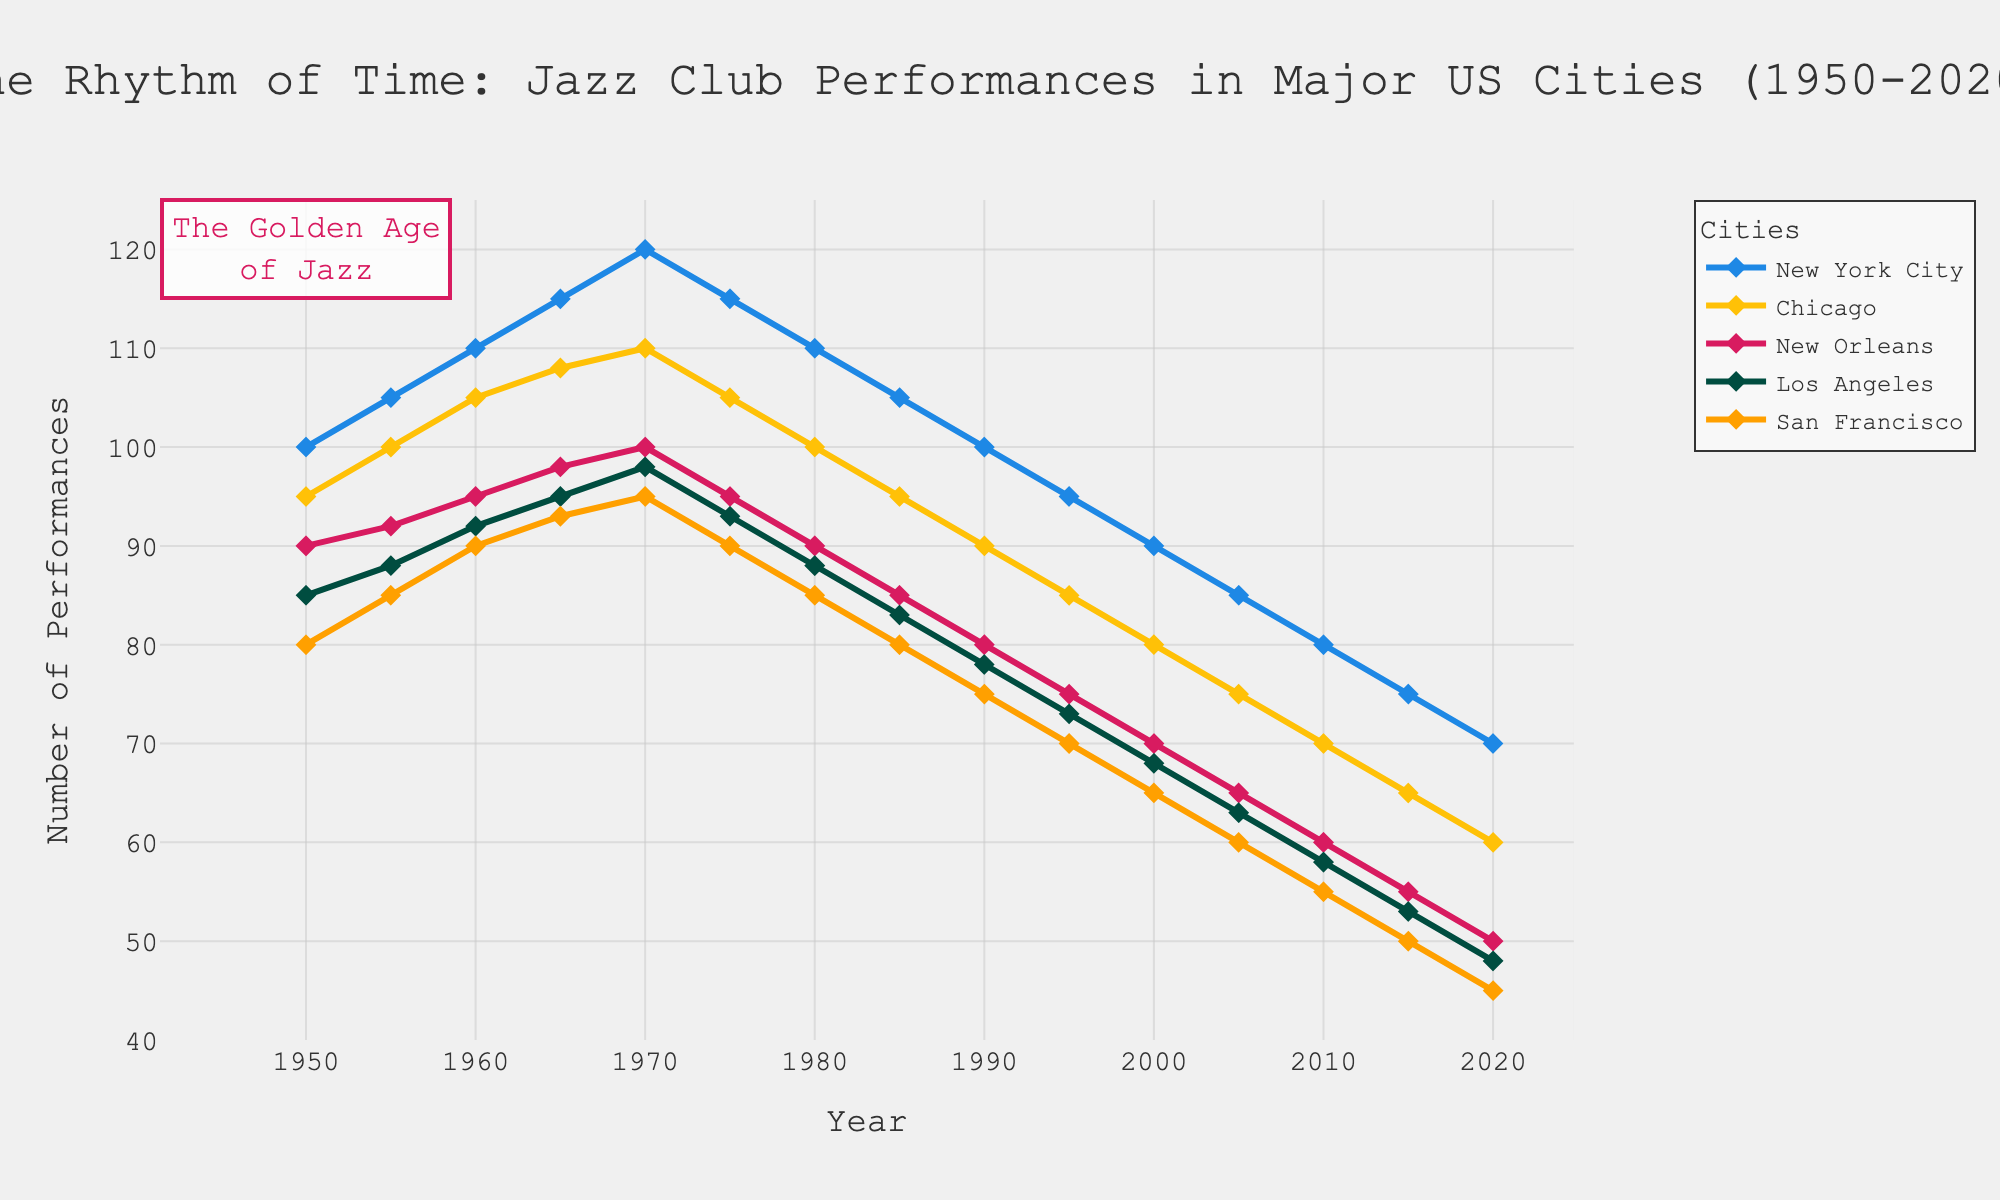Which city had the highest number of performances in 1970? By observing the line chart, we can see that New York City had the highest number of performances in 1970.
Answer: New York City How many performances did New Orleans have in 1985, and how does that compare to the number in 1950? New Orleans had 85 performances in 1985. By looking at 1950, we see it had 90 performances. Comparing the two, in 1985 there was 5 performances fewer than in 1950.
Answer: 85 in 1985, 5 fewer than in 1950 What is the average number of performances in Chicago from 2000 to 2020? The number of performances in Chicago from 2000 to 2020 is 80, 75, 70, 65, 60. Summing these up (80 + 75 + 70 + 65 + 60) = 350, and there are 5 data points, so the average is 350 / 5 = 70
Answer: 70 Which city showed the most significant decline in performances from 1950 to 2020? By comparing the drop in performances from 1950 to 2020 for each city, we see that New York City had 100 performances in 1950, which fell to 70 by 2020, a decline of 30, the largest among the cities.
Answer: New York City Between which consecutive decades did San Francisco’s performances drop the most? Looking at San Francisco's trend, the biggest drop is from 1965 (93) to 1975 (90), a decline of 3.
Answer: 1965-1975 What are the changes in the number of performances in Los Angeles from 1980 to 1990? The number of performances in Los Angeles was 88 in 1980 and 78 in 1990. Subtracting the latter from the former gives 88 - 78 = 10, meaning there is a drop of 10 performances.
Answer: Drop of 10 In which year did New York City have 120 performances? By observing the line chart, we see that New York City had 120 performances in the year 1970.
Answer: 1970 How does the number of performances in New Orleans in 1970 compare to that in Chicago in 2020? The number of performances in New Orleans in 1970 was 100, and in Chicago in 2020 it was 60. Therefore, New Orleans had 40 more performances in 1970 compared to Chicago in 2020.
Answer: 40 more What is the trend of performances in San Francisco from 1950 to 2020? By observing the graph, the performances in San Francisco show a consistent decline from 1950 (80 performances) to 2020 (45 performances).
Answer: Consistent decline 